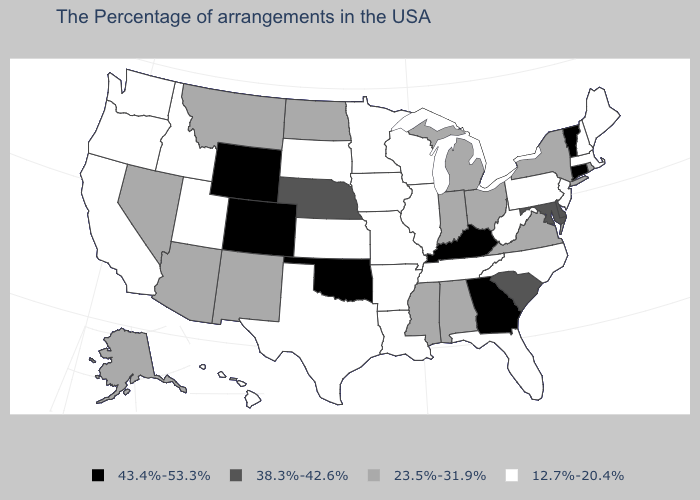Among the states that border Arkansas , which have the lowest value?
Give a very brief answer. Tennessee, Louisiana, Missouri, Texas. Among the states that border Arkansas , which have the lowest value?
Quick response, please. Tennessee, Louisiana, Missouri, Texas. Does the first symbol in the legend represent the smallest category?
Concise answer only. No. Which states hav the highest value in the MidWest?
Keep it brief. Nebraska. Does Kansas have the lowest value in the USA?
Write a very short answer. Yes. What is the value of Minnesota?
Answer briefly. 12.7%-20.4%. Name the states that have a value in the range 12.7%-20.4%?
Keep it brief. Maine, Massachusetts, New Hampshire, New Jersey, Pennsylvania, North Carolina, West Virginia, Florida, Tennessee, Wisconsin, Illinois, Louisiana, Missouri, Arkansas, Minnesota, Iowa, Kansas, Texas, South Dakota, Utah, Idaho, California, Washington, Oregon, Hawaii. Does the map have missing data?
Quick response, please. No. Does Massachusetts have the highest value in the USA?
Answer briefly. No. What is the lowest value in the MidWest?
Concise answer only. 12.7%-20.4%. What is the value of Nevada?
Keep it brief. 23.5%-31.9%. Among the states that border South Carolina , which have the lowest value?
Keep it brief. North Carolina. Does the map have missing data?
Be succinct. No. Name the states that have a value in the range 43.4%-53.3%?
Keep it brief. Vermont, Connecticut, Georgia, Kentucky, Oklahoma, Wyoming, Colorado. 